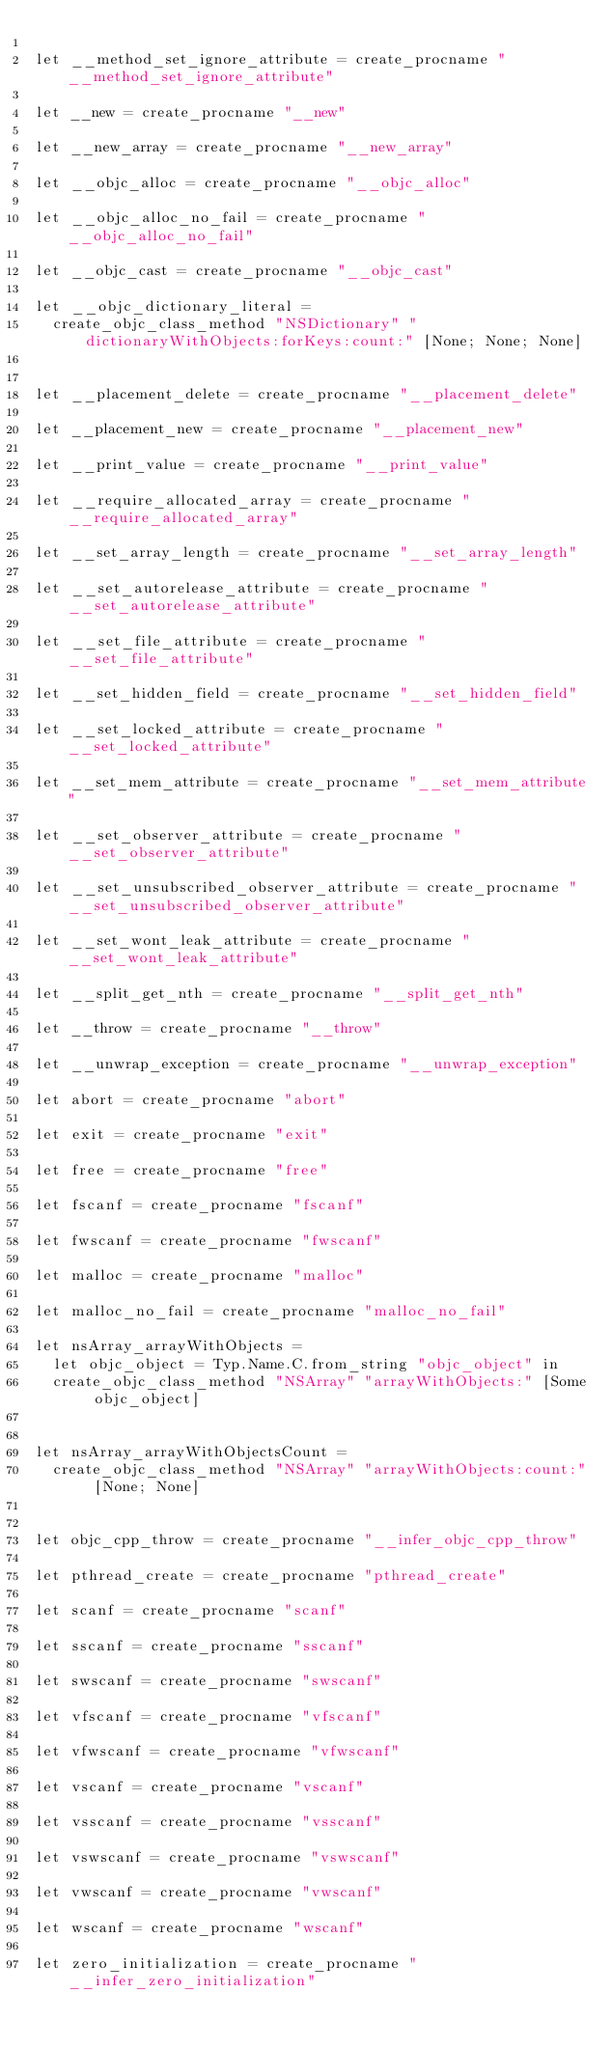Convert code to text. <code><loc_0><loc_0><loc_500><loc_500><_OCaml_>
let __method_set_ignore_attribute = create_procname "__method_set_ignore_attribute"

let __new = create_procname "__new"

let __new_array = create_procname "__new_array"

let __objc_alloc = create_procname "__objc_alloc"

let __objc_alloc_no_fail = create_procname "__objc_alloc_no_fail"

let __objc_cast = create_procname "__objc_cast"

let __objc_dictionary_literal =
  create_objc_class_method "NSDictionary" "dictionaryWithObjects:forKeys:count:" [None; None; None]


let __placement_delete = create_procname "__placement_delete"

let __placement_new = create_procname "__placement_new"

let __print_value = create_procname "__print_value"

let __require_allocated_array = create_procname "__require_allocated_array"

let __set_array_length = create_procname "__set_array_length"

let __set_autorelease_attribute = create_procname "__set_autorelease_attribute"

let __set_file_attribute = create_procname "__set_file_attribute"

let __set_hidden_field = create_procname "__set_hidden_field"

let __set_locked_attribute = create_procname "__set_locked_attribute"

let __set_mem_attribute = create_procname "__set_mem_attribute"

let __set_observer_attribute = create_procname "__set_observer_attribute"

let __set_unsubscribed_observer_attribute = create_procname "__set_unsubscribed_observer_attribute"

let __set_wont_leak_attribute = create_procname "__set_wont_leak_attribute"

let __split_get_nth = create_procname "__split_get_nth"

let __throw = create_procname "__throw"

let __unwrap_exception = create_procname "__unwrap_exception"

let abort = create_procname "abort"

let exit = create_procname "exit"

let free = create_procname "free"

let fscanf = create_procname "fscanf"

let fwscanf = create_procname "fwscanf"

let malloc = create_procname "malloc"

let malloc_no_fail = create_procname "malloc_no_fail"

let nsArray_arrayWithObjects =
  let objc_object = Typ.Name.C.from_string "objc_object" in
  create_objc_class_method "NSArray" "arrayWithObjects:" [Some objc_object]


let nsArray_arrayWithObjectsCount =
  create_objc_class_method "NSArray" "arrayWithObjects:count:" [None; None]


let objc_cpp_throw = create_procname "__infer_objc_cpp_throw"

let pthread_create = create_procname "pthread_create"

let scanf = create_procname "scanf"

let sscanf = create_procname "sscanf"

let swscanf = create_procname "swscanf"

let vfscanf = create_procname "vfscanf"

let vfwscanf = create_procname "vfwscanf"

let vscanf = create_procname "vscanf"

let vsscanf = create_procname "vsscanf"

let vswscanf = create_procname "vswscanf"

let vwscanf = create_procname "vwscanf"

let wscanf = create_procname "wscanf"

let zero_initialization = create_procname "__infer_zero_initialization"
</code> 